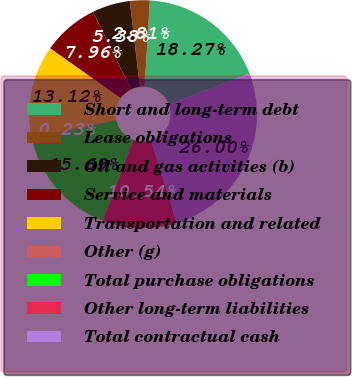<chart> <loc_0><loc_0><loc_500><loc_500><pie_chart><fcel>Short and long-term debt<fcel>Lease obligations<fcel>Oil and gas activities (b)<fcel>Service and materials<fcel>Transportation and related<fcel>Other (g)<fcel>Total purchase obligations<fcel>Other long-term liabilities<fcel>Total contractual cash<nl><fcel>18.27%<fcel>2.81%<fcel>5.38%<fcel>7.96%<fcel>13.12%<fcel>0.23%<fcel>15.69%<fcel>10.54%<fcel>26.0%<nl></chart> 